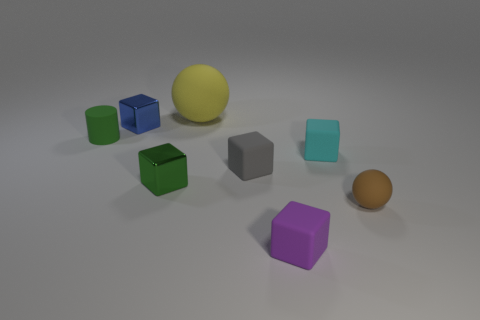Subtract all green metal blocks. How many blocks are left? 4 Add 1 cyan metallic blocks. How many objects exist? 9 Subtract all purple cubes. How many cubes are left? 4 Subtract 2 spheres. How many spheres are left? 0 Subtract all cylinders. How many objects are left? 7 Subtract 0 purple cylinders. How many objects are left? 8 Subtract all red balls. Subtract all cyan blocks. How many balls are left? 2 Subtract all green shiny blocks. Subtract all tiny green matte things. How many objects are left? 6 Add 2 big rubber things. How many big rubber things are left? 3 Add 4 brown matte things. How many brown matte things exist? 5 